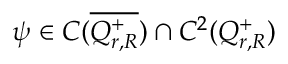<formula> <loc_0><loc_0><loc_500><loc_500>\psi \in C ( \overline { { Q _ { r , R } ^ { + } } } ) \cap C ^ { 2 } ( Q _ { r , R } ^ { + } )</formula> 